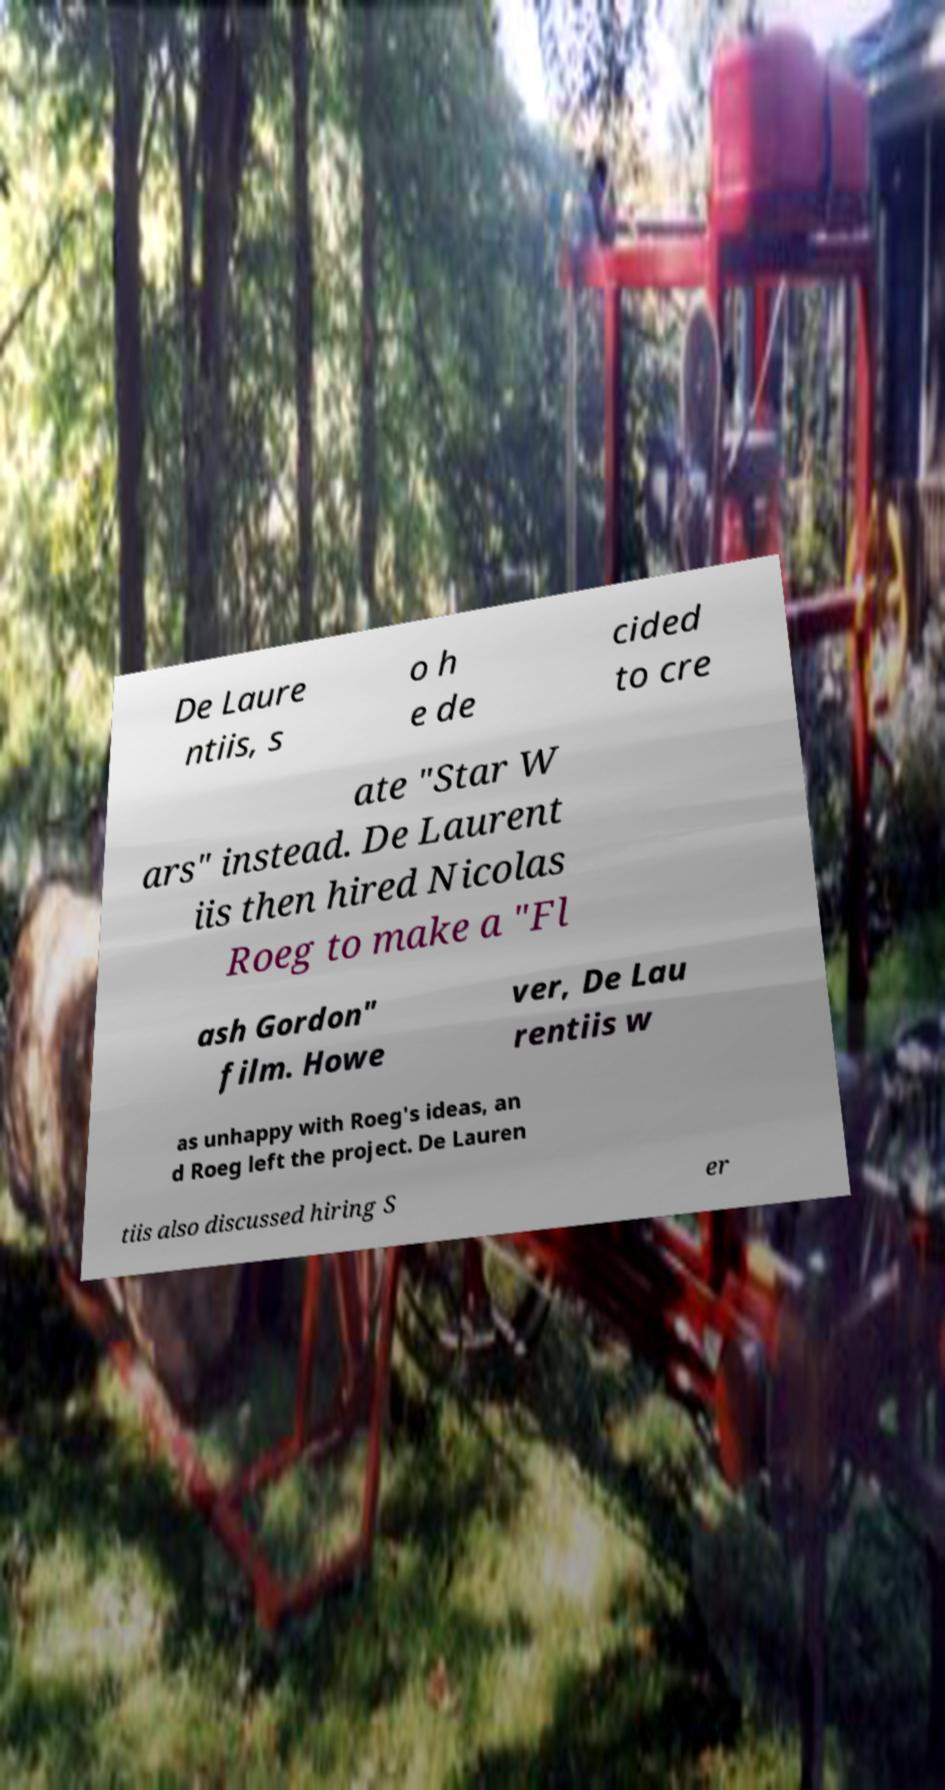Please read and relay the text visible in this image. What does it say? De Laure ntiis, s o h e de cided to cre ate "Star W ars" instead. De Laurent iis then hired Nicolas Roeg to make a "Fl ash Gordon" film. Howe ver, De Lau rentiis w as unhappy with Roeg's ideas, an d Roeg left the project. De Lauren tiis also discussed hiring S er 